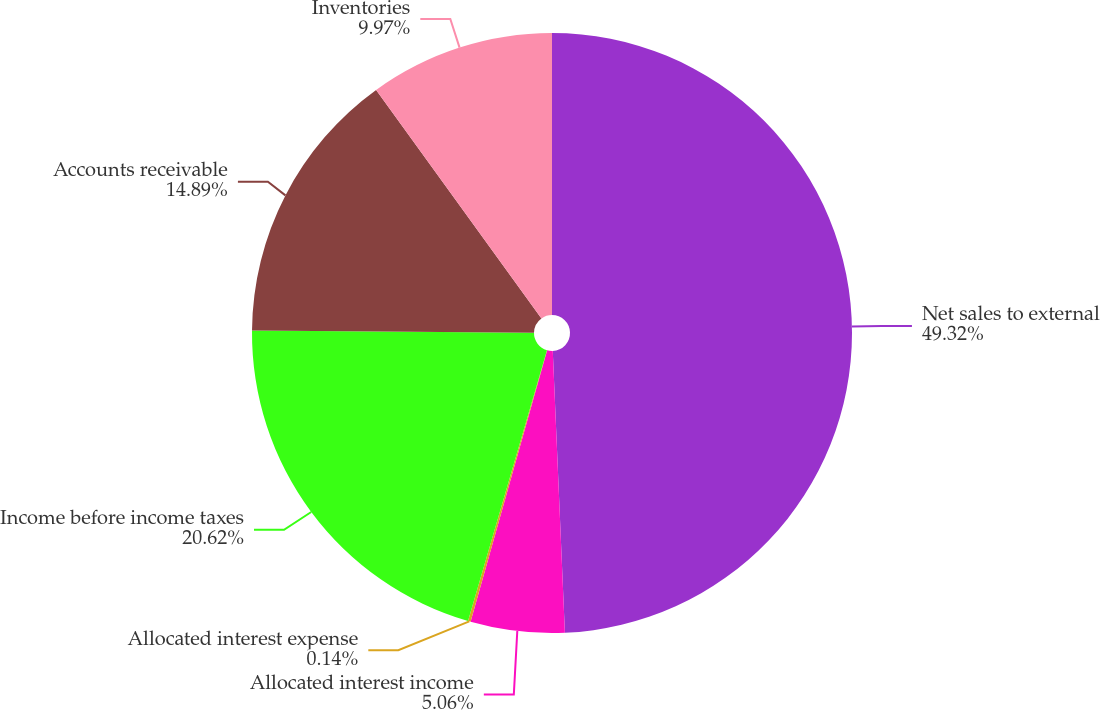Convert chart. <chart><loc_0><loc_0><loc_500><loc_500><pie_chart><fcel>Net sales to external<fcel>Allocated interest income<fcel>Allocated interest expense<fcel>Income before income taxes<fcel>Accounts receivable<fcel>Inventories<nl><fcel>49.31%<fcel>5.06%<fcel>0.14%<fcel>20.62%<fcel>14.89%<fcel>9.97%<nl></chart> 